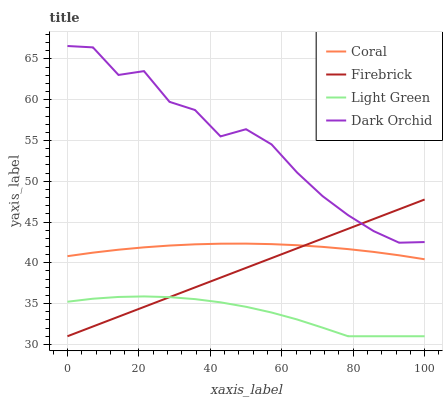Does Light Green have the minimum area under the curve?
Answer yes or no. Yes. Does Dark Orchid have the maximum area under the curve?
Answer yes or no. Yes. Does Coral have the minimum area under the curve?
Answer yes or no. No. Does Coral have the maximum area under the curve?
Answer yes or no. No. Is Firebrick the smoothest?
Answer yes or no. Yes. Is Dark Orchid the roughest?
Answer yes or no. Yes. Is Coral the smoothest?
Answer yes or no. No. Is Coral the roughest?
Answer yes or no. No. Does Firebrick have the lowest value?
Answer yes or no. Yes. Does Coral have the lowest value?
Answer yes or no. No. Does Dark Orchid have the highest value?
Answer yes or no. Yes. Does Coral have the highest value?
Answer yes or no. No. Is Coral less than Dark Orchid?
Answer yes or no. Yes. Is Dark Orchid greater than Light Green?
Answer yes or no. Yes. Does Firebrick intersect Dark Orchid?
Answer yes or no. Yes. Is Firebrick less than Dark Orchid?
Answer yes or no. No. Is Firebrick greater than Dark Orchid?
Answer yes or no. No. Does Coral intersect Dark Orchid?
Answer yes or no. No. 